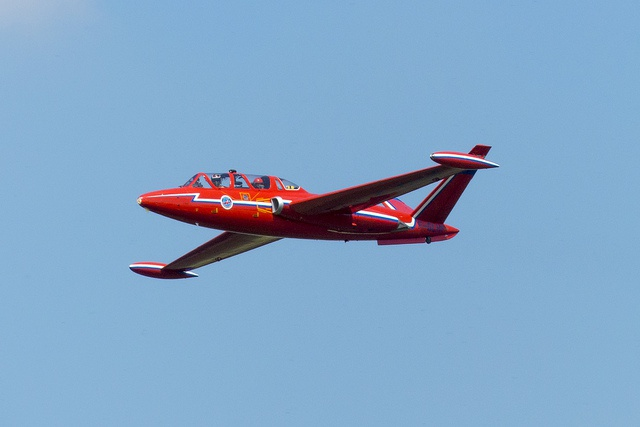Describe the objects in this image and their specific colors. I can see airplane in lightblue, black, maroon, red, and brown tones, people in lightblue, gray, navy, blue, and purple tones, and people in lightblue, gray, salmon, black, and purple tones in this image. 